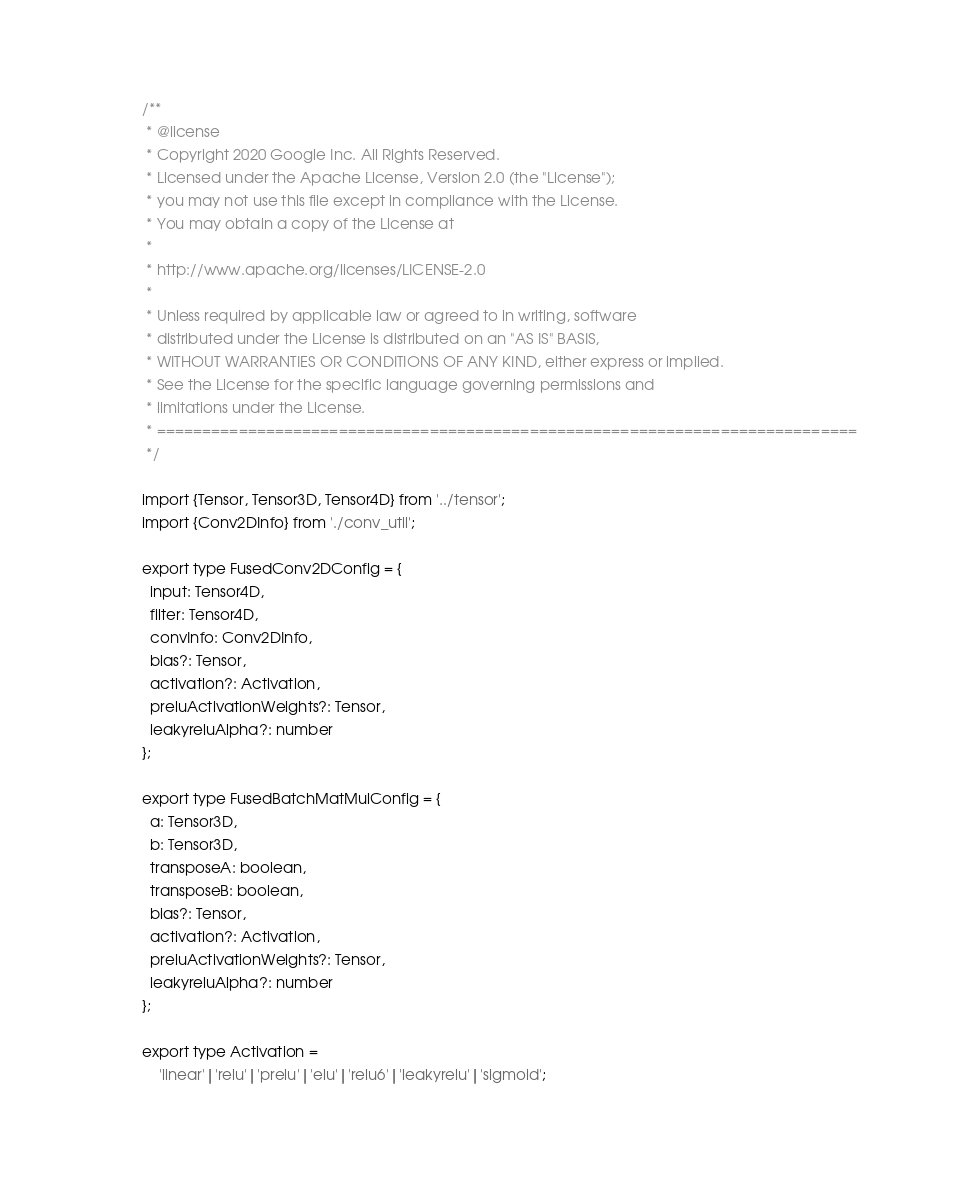Convert code to text. <code><loc_0><loc_0><loc_500><loc_500><_TypeScript_>/**
 * @license
 * Copyright 2020 Google Inc. All Rights Reserved.
 * Licensed under the Apache License, Version 2.0 (the "License");
 * you may not use this file except in compliance with the License.
 * You may obtain a copy of the License at
 *
 * http://www.apache.org/licenses/LICENSE-2.0
 *
 * Unless required by applicable law or agreed to in writing, software
 * distributed under the License is distributed on an "AS IS" BASIS,
 * WITHOUT WARRANTIES OR CONDITIONS OF ANY KIND, either express or implied.
 * See the License for the specific language governing permissions and
 * limitations under the License.
 * =============================================================================
 */

import {Tensor, Tensor3D, Tensor4D} from '../tensor';
import {Conv2DInfo} from './conv_util';

export type FusedConv2DConfig = {
  input: Tensor4D,
  filter: Tensor4D,
  convInfo: Conv2DInfo,
  bias?: Tensor,
  activation?: Activation,
  preluActivationWeights?: Tensor,
  leakyreluAlpha?: number
};

export type FusedBatchMatMulConfig = {
  a: Tensor3D,
  b: Tensor3D,
  transposeA: boolean,
  transposeB: boolean,
  bias?: Tensor,
  activation?: Activation,
  preluActivationWeights?: Tensor,
  leakyreluAlpha?: number
};

export type Activation =
    'linear'|'relu'|'prelu'|'elu'|'relu6'|'leakyrelu'|'sigmoid';
</code> 